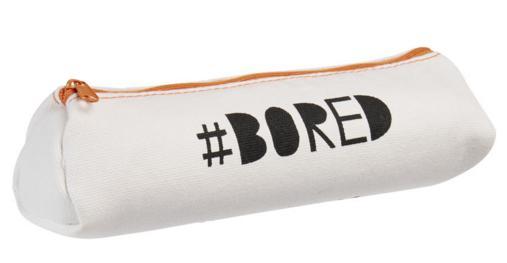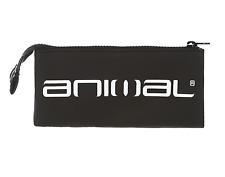The first image is the image on the left, the second image is the image on the right. For the images shown, is this caption "Both pouches have the word """"animal"""" on them." true? Answer yes or no. No. 